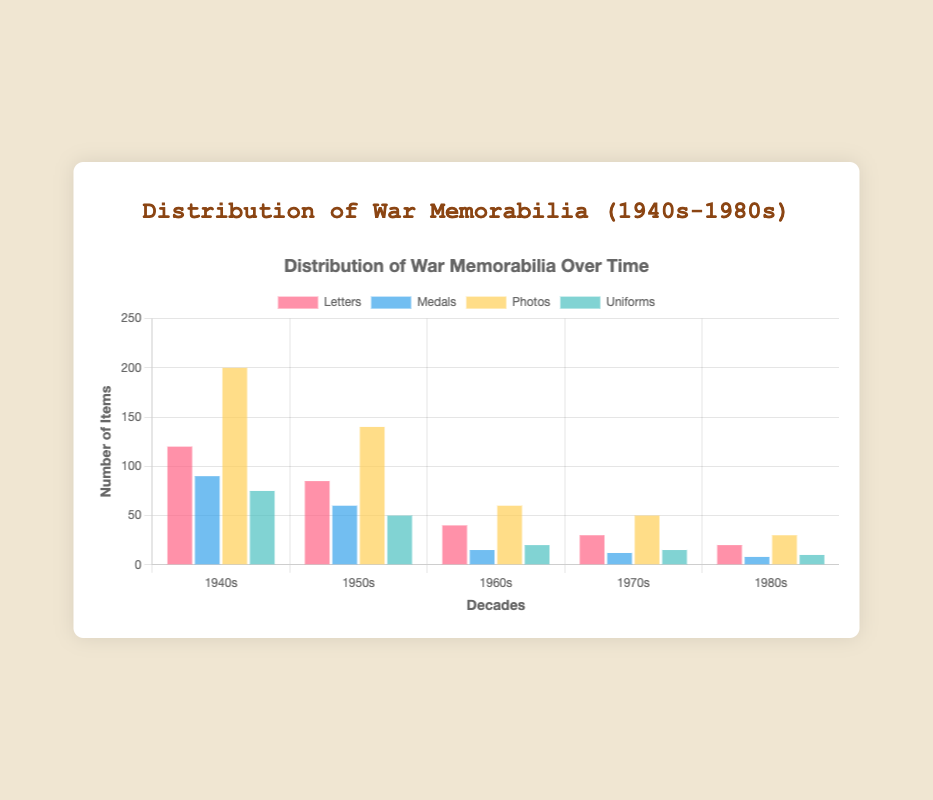Which decade has the highest number of photos? Look at the height of the bars representing photos across all decades. The tallest bar is in the 1940s.
Answer: 1940s How many more letters are there in the 1940s compared to the 1980s? Subtract the number of letters in the 1980s (20) from the number of letters in the 1940s (120). 120 - 20 = 100
Answer: 100 Which type of memorabilia is the most evenly distributed across all decades? Compare the heights of the bars of each type of memorabilia across the decades. Uniforms have the smallest variation in bar heights across decades.
Answer: Uniforms What is the total number of medals and photos in the 1950s? Add the number of medals (60) to the number of photos (140). 60 + 140 = 200
Answer: 200 By how much does the number of medals decrease from the 1940s to the 1960s? Subtract the number of medals in the 1960s (15) from the number of medals in the 1940s (90). 90 - 15 = 75
Answer: 75 Are there more photos or uniforms in the 1960s? Compare the bars representing photos (60) and uniforms (20) in the 1960s. The bar for photos is taller.
Answer: Photos Which decade has the lowest total number of memorabilia items for all types combined? Sum the values of letters, medals, photos, and uniforms for each decade and compare. The 1980s have the lowest total: 20 (letters) + 8 (medals) + 30 (photos) + 10 (uniforms) = 68
Answer: 1980s How many more letters are there than medals in the 1950s? Subtract the number of medals (60) from the number of letters (85) in the 1950s. 85 - 60 = 25
Answer: 25 In which decade do uniforms have the least increase compared to the previous decade? Compare the increase in the number of uniforms for each decade change. The increase is the smallest from the 1970s to the 1980s (15 to 10 = -5).
Answer: 1980s 